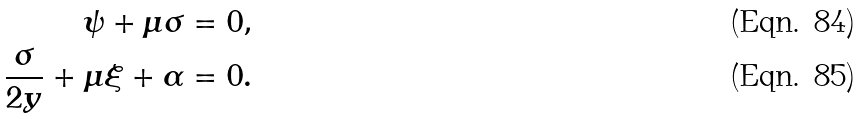<formula> <loc_0><loc_0><loc_500><loc_500>\psi + \mu \sigma = 0 , \\ \frac { \sigma } { 2 y } + \mu \xi + \alpha = 0 .</formula> 